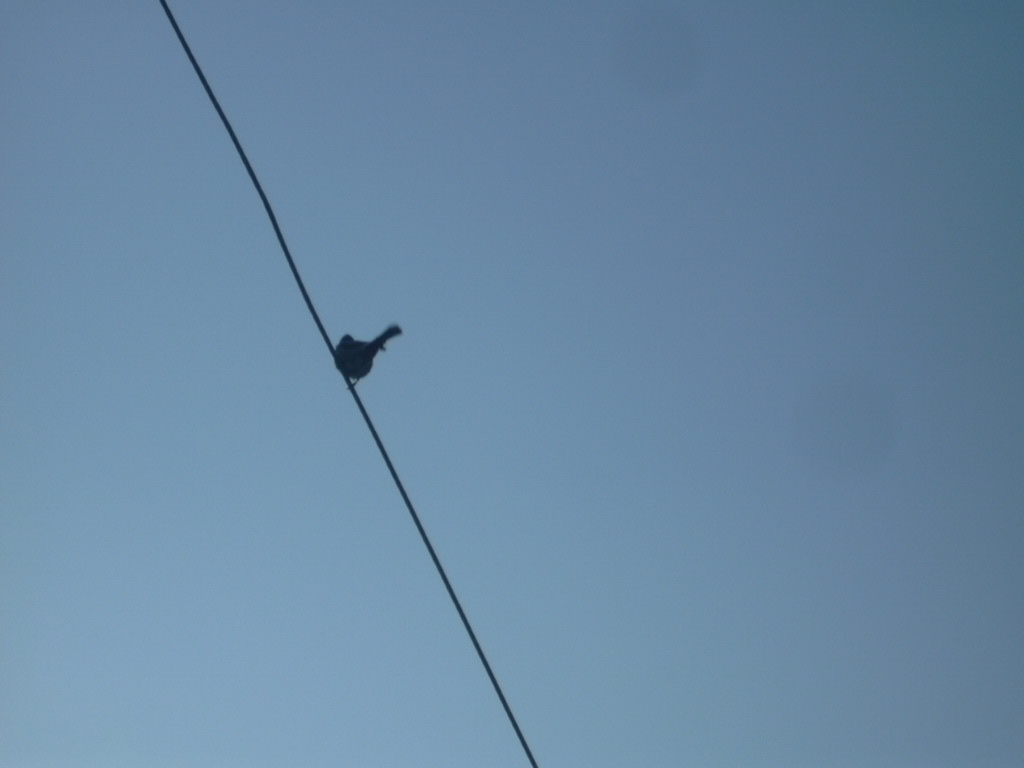Is there any significance to the bird being alone in the image? The lone bird could signify solitude or peacefulness. Visually, it creates a simple and stark image that contrasts the vastness of the sky with the smallness of the individual bird. 